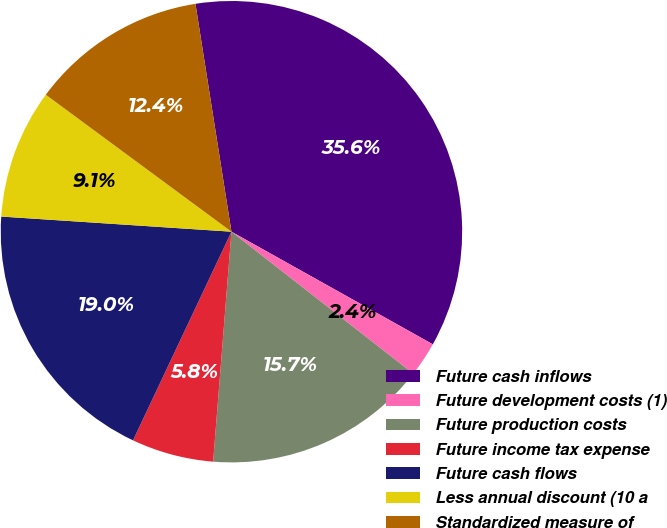Convert chart. <chart><loc_0><loc_0><loc_500><loc_500><pie_chart><fcel>Future cash inflows<fcel>Future development costs (1)<fcel>Future production costs<fcel>Future income tax expense<fcel>Future cash flows<fcel>Less annual discount (10 a<fcel>Standardized measure of<nl><fcel>35.61%<fcel>2.44%<fcel>15.71%<fcel>5.75%<fcel>19.03%<fcel>9.07%<fcel>12.39%<nl></chart> 